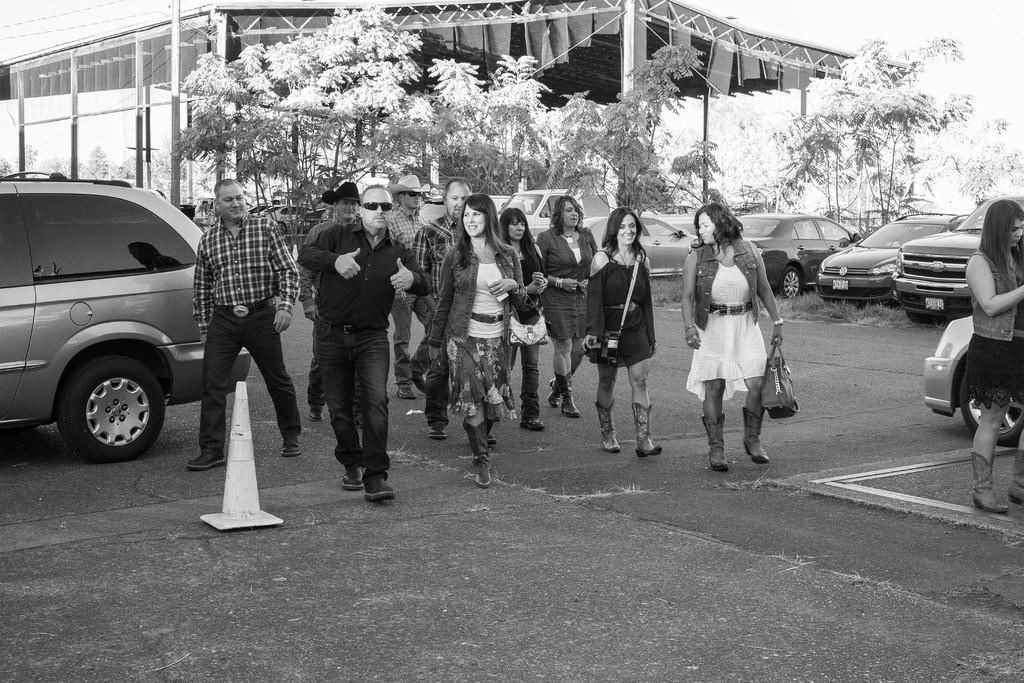What are the people in the image doing? The people in the image are walking. What else can be seen in the image besides the people? There are many cars in the image. What type of structure is depicted in the image? The image depicts a shelter. What can be seen in the background of the image? There are trees in the background of the image. What color is the clam in the image? There is no clam present in the image. How does the pest affect the people in the image? There is no mention of a pest in the image, so it cannot affect the people. 